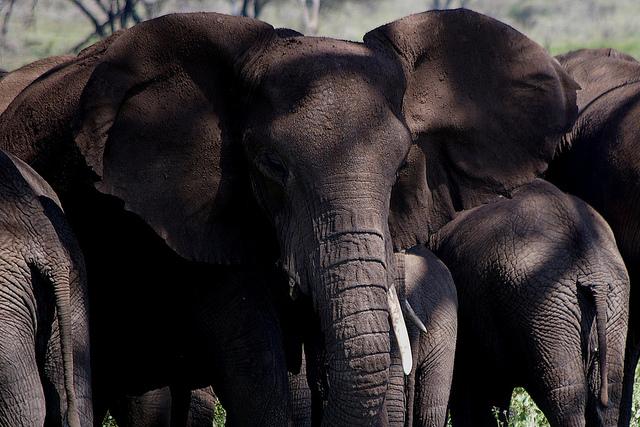What part of the elephants are touching one another?
Concise answer only. Sides. Is there an elephant tail in the picture?
Keep it brief. Yes. Are there pieces of grass on its face?
Concise answer only. No. Are the elephants free?
Write a very short answer. Yes. How many elephants are in this scene?
Quick response, please. 5. How many elephants?
Quick response, please. 5. How many elephant tusk are in this image?
Short answer required. 1. How many elephants are in this picture?
Quick response, please. 5. Why can't we see the back elephant's right eye?
Short answer required. Shadow. Are they wild elephants?
Write a very short answer. Yes. 